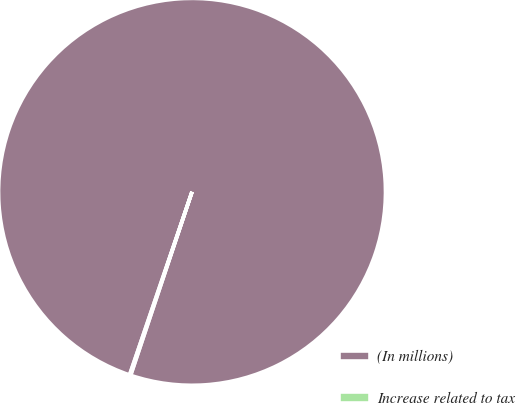Convert chart. <chart><loc_0><loc_0><loc_500><loc_500><pie_chart><fcel>(In millions)<fcel>Increase related to tax<nl><fcel>99.9%<fcel>0.1%<nl></chart> 